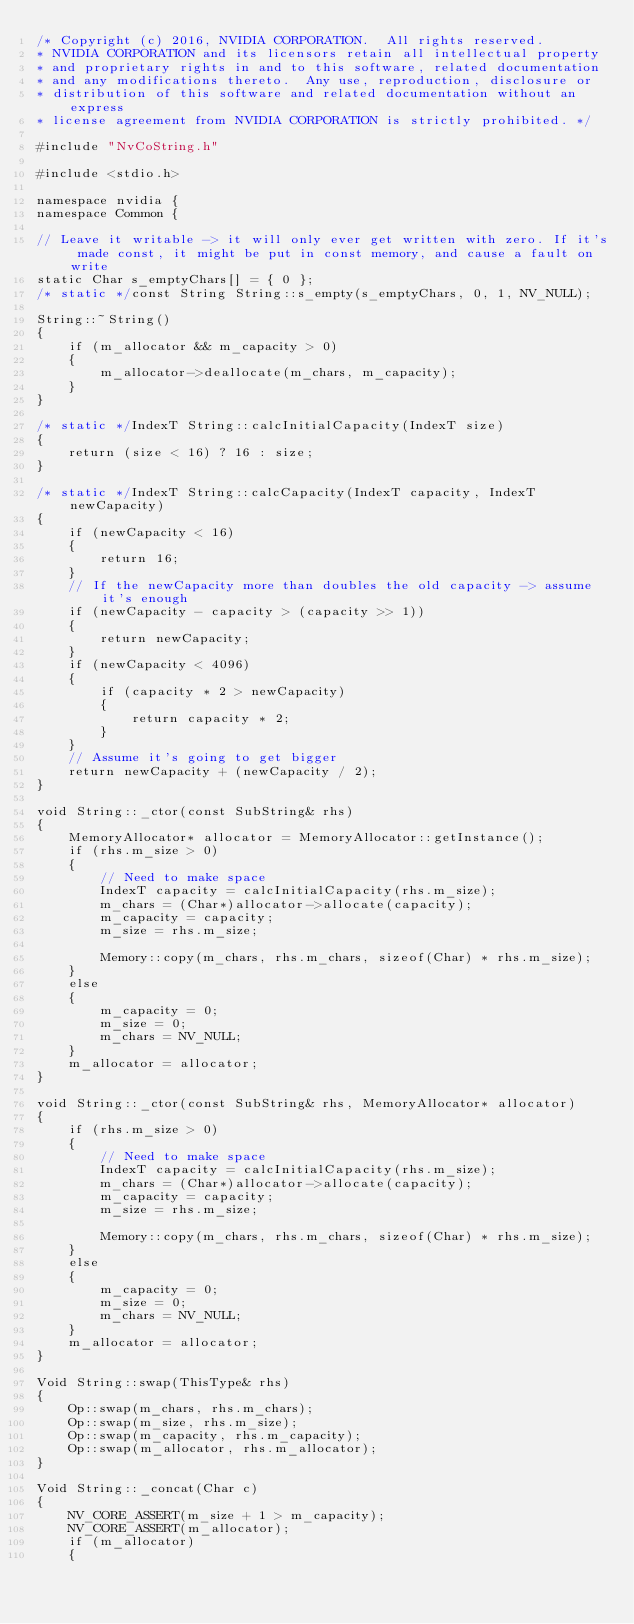<code> <loc_0><loc_0><loc_500><loc_500><_C++_>/* Copyright (c) 2016, NVIDIA CORPORATION.  All rights reserved.
* NVIDIA CORPORATION and its licensors retain all intellectual property
* and proprietary rights in and to this software, related documentation
* and any modifications thereto.  Any use, reproduction, disclosure or
* distribution of this software and related documentation without an express
* license agreement from NVIDIA CORPORATION is strictly prohibited. */

#include "NvCoString.h"

#include <stdio.h>

namespace nvidia {
namespace Common {

// Leave it writable -> it will only ever get written with zero. If it's made const, it might be put in const memory, and cause a fault on write
static Char s_emptyChars[] = { 0 };
/* static */const String String::s_empty(s_emptyChars, 0, 1, NV_NULL);

String::~String()
{
	if (m_allocator && m_capacity > 0)
	{
		m_allocator->deallocate(m_chars, m_capacity);
	}
}

/* static */IndexT String::calcInitialCapacity(IndexT size)
{
	return (size < 16) ? 16 : size;
}

/* static */IndexT String::calcCapacity(IndexT capacity, IndexT newCapacity)
{
	if (newCapacity < 16)
	{
		return 16;
	}
	// If the newCapacity more than doubles the old capacity -> assume it's enough
	if (newCapacity - capacity > (capacity >> 1))
	{
		return newCapacity;
	}
	if (newCapacity < 4096)
	{
		if (capacity * 2 > newCapacity)
		{
			return capacity * 2;
		}
	}
	// Assume it's going to get bigger
	return newCapacity + (newCapacity / 2);
}

void String::_ctor(const SubString& rhs)
{
	MemoryAllocator* allocator = MemoryAllocator::getInstance();
	if (rhs.m_size > 0)
	{
		// Need to make space
		IndexT capacity = calcInitialCapacity(rhs.m_size);
		m_chars = (Char*)allocator->allocate(capacity);
		m_capacity = capacity;
		m_size = rhs.m_size;

		Memory::copy(m_chars, rhs.m_chars, sizeof(Char) * rhs.m_size);
	}
	else
	{
		m_capacity = 0;
		m_size = 0;
		m_chars = NV_NULL;
	}
	m_allocator = allocator;
}

void String::_ctor(const SubString& rhs, MemoryAllocator* allocator)
{
	if (rhs.m_size > 0)
	{
		// Need to make space
		IndexT capacity = calcInitialCapacity(rhs.m_size);
		m_chars = (Char*)allocator->allocate(capacity);
		m_capacity = capacity;
		m_size = rhs.m_size;

		Memory::copy(m_chars, rhs.m_chars, sizeof(Char) * rhs.m_size);
	}
	else
	{
		m_capacity = 0;
		m_size = 0;
		m_chars = NV_NULL;
	}
	m_allocator = allocator;
}

Void String::swap(ThisType& rhs)
{
	Op::swap(m_chars, rhs.m_chars);
	Op::swap(m_size, rhs.m_size);
	Op::swap(m_capacity, rhs.m_capacity);
	Op::swap(m_allocator, rhs.m_allocator);
}

Void String::_concat(Char c)
{
	NV_CORE_ASSERT(m_size + 1 > m_capacity);
	NV_CORE_ASSERT(m_allocator);
	if (m_allocator)
	{</code> 